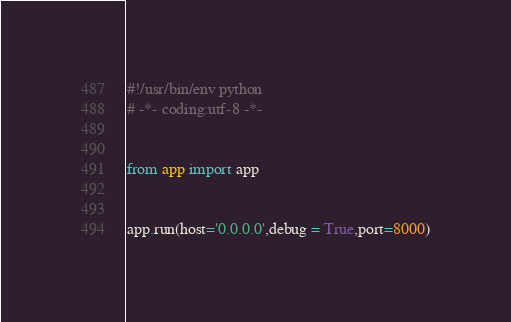Convert code to text. <code><loc_0><loc_0><loc_500><loc_500><_Python_>#!/usr/bin/env python
# -*- coding:utf-8 -*-


from app import app


app.run(host='0.0.0.0',debug = True,port=8000)</code> 